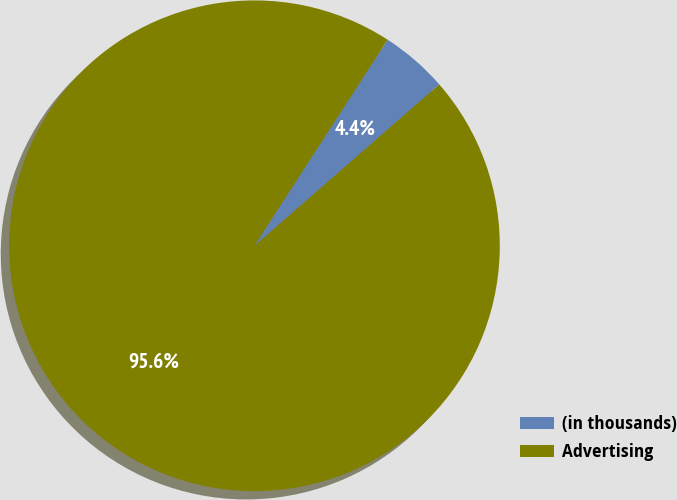Convert chart to OTSL. <chart><loc_0><loc_0><loc_500><loc_500><pie_chart><fcel>(in thousands)<fcel>Advertising<nl><fcel>4.45%<fcel>95.55%<nl></chart> 